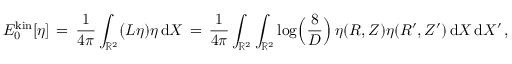<formula> <loc_0><loc_0><loc_500><loc_500>E _ { 0 } ^ { k i n } [ \eta ] \, = \, \frac { 1 } { 4 \pi } \int _ { \mathbb { R } ^ { 2 } } \Big ( L \eta ) \eta \, d X \, = \, \frac { 1 } { 4 \pi } \int _ { \mathbb { R } ^ { 2 } } \int _ { \mathbb { R } ^ { 2 } } \log \Big ( \frac { 8 } { D } \Big ) \, \eta ( R , Z ) \eta ( R ^ { \prime } , Z ^ { \prime } ) \, d X \, d X ^ { \prime } \, ,</formula> 